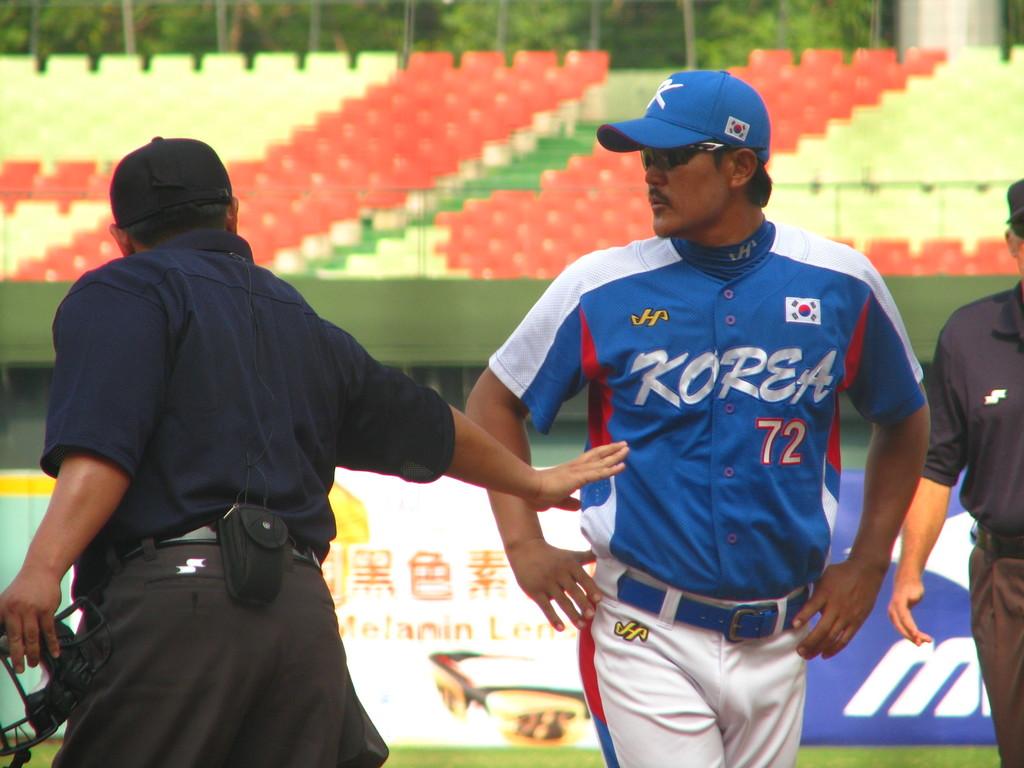What country is listed on the jersey?
Your answer should be very brief. Korea. What number is on this player's jersey?
Provide a succinct answer. 72. 